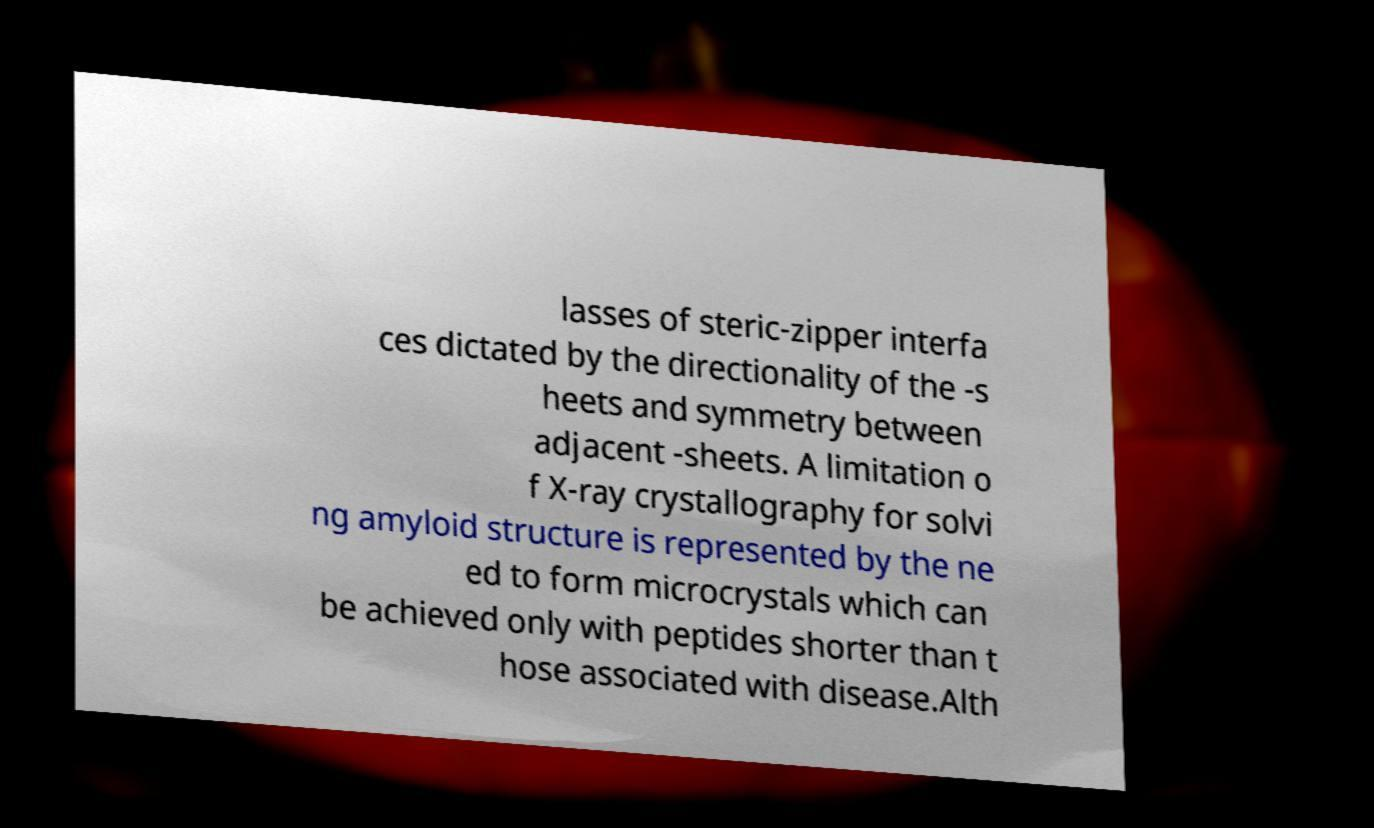I need the written content from this picture converted into text. Can you do that? lasses of steric-zipper interfa ces dictated by the directionality of the -s heets and symmetry between adjacent -sheets. A limitation o f X-ray crystallography for solvi ng amyloid structure is represented by the ne ed to form microcrystals which can be achieved only with peptides shorter than t hose associated with disease.Alth 